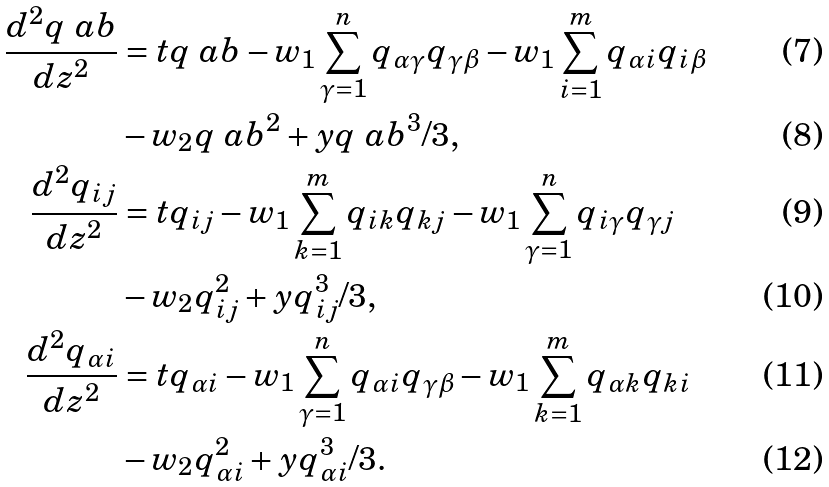<formula> <loc_0><loc_0><loc_500><loc_500>\frac { d ^ { 2 } q \ a b } { d z ^ { 2 } } & = t q \ a b - w _ { 1 } \sum _ { \gamma = 1 } ^ { n } q _ { \alpha \gamma } q _ { \gamma \beta } - w _ { 1 } \sum _ { i = 1 } ^ { m } q _ { \alpha i } q _ { i \beta } \\ & - w _ { 2 } q \ a b ^ { 2 } + y q \ a b ^ { 3 } / 3 , \\ \frac { d ^ { 2 } q _ { i j } } { d z ^ { 2 } } & = t q _ { i j } - w _ { 1 } \sum _ { k = 1 } ^ { m } q _ { i k } q _ { k j } - w _ { 1 } \sum _ { \gamma = 1 } ^ { n } q _ { i \gamma } q _ { \gamma j } \\ & - w _ { 2 } q _ { i j } ^ { 2 } + y q _ { i j } ^ { 3 } / 3 , \\ \frac { d ^ { 2 } q _ { \alpha i } } { d z ^ { 2 } } & = t q _ { \alpha i } - w _ { 1 } \sum _ { \gamma = 1 } ^ { n } q _ { \alpha i } q _ { \gamma \beta } - w _ { 1 } \sum _ { k = 1 } ^ { m } q _ { \alpha k } q _ { k i } \\ & - w _ { 2 } q _ { \alpha i } ^ { 2 } + y q _ { \alpha i } ^ { 3 } / 3 .</formula> 